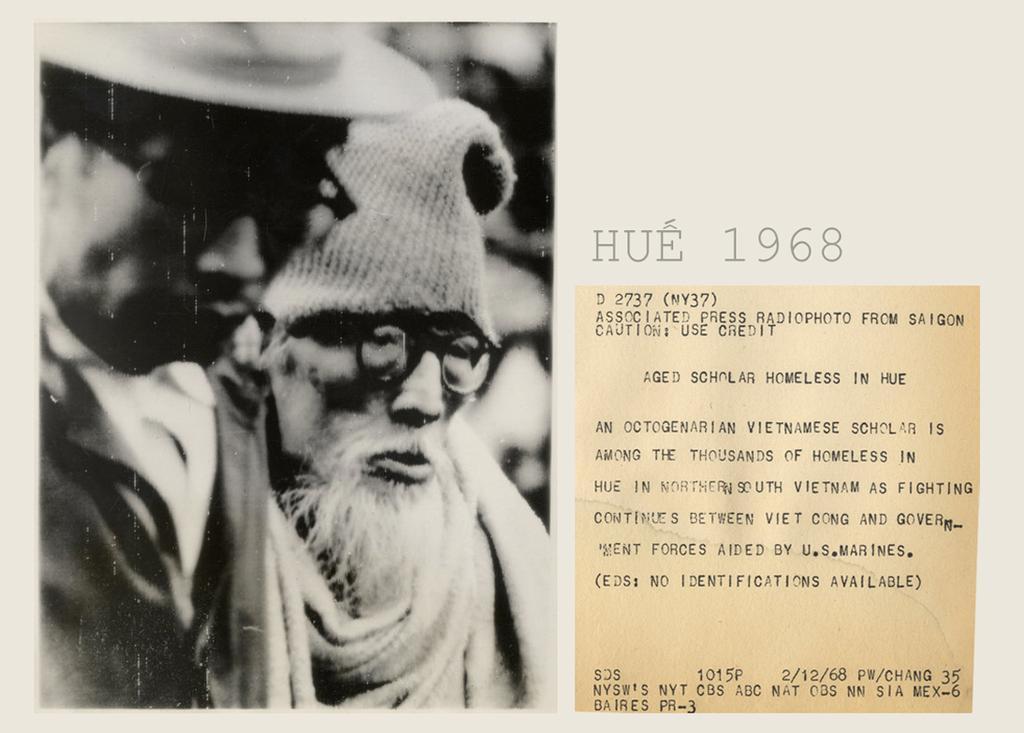Can you describe this image briefly? This is the picture of a paper in which there is a picture of two people and something written in the right side of the picture. 